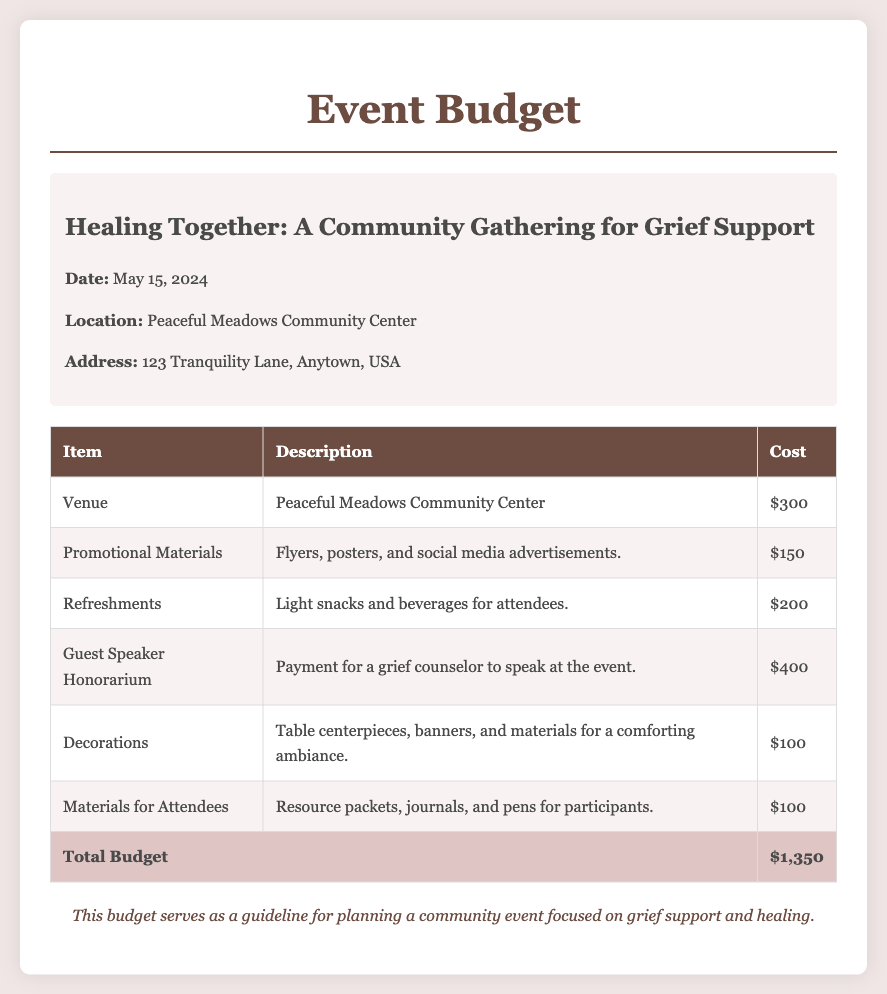What is the date of the event? The date of the event is provided in the document, which states it is on May 15, 2024.
Answer: May 15, 2024 What is the location of the event? The location is specified in the document as Peaceful Meadows Community Center.
Answer: Peaceful Meadows Community Center How much is allocated for refreshments? The budget includes a specific cost for refreshments, which is stated as $200.
Answer: $200 What is the total budget for the event? The total budget is summarized at the end of the table, showing the total as $1,350.
Answer: $1,350 What type of materials are provided for attendees? The document mentions that resource packets, journals, and pens are included in the budget for attendees.
Answer: Resource packets, journals, and pens How much is the guest speaker honorarium? The cost for the guest speaker's honorarium is listed in the document as $400.
Answer: $400 What is the cost for promotional materials? The budget details the cost for promotional materials, which is specified as $150.
Answer: $150 What is included in the venue cost? The venue cost refers to the Peaceful Meadows Community Center, as stated in the document.
Answer: Peaceful Meadows Community Center What is the purpose of the event? The title of the event suggests that the purpose is focused on grief support and healing.
Answer: Grief support and healing 